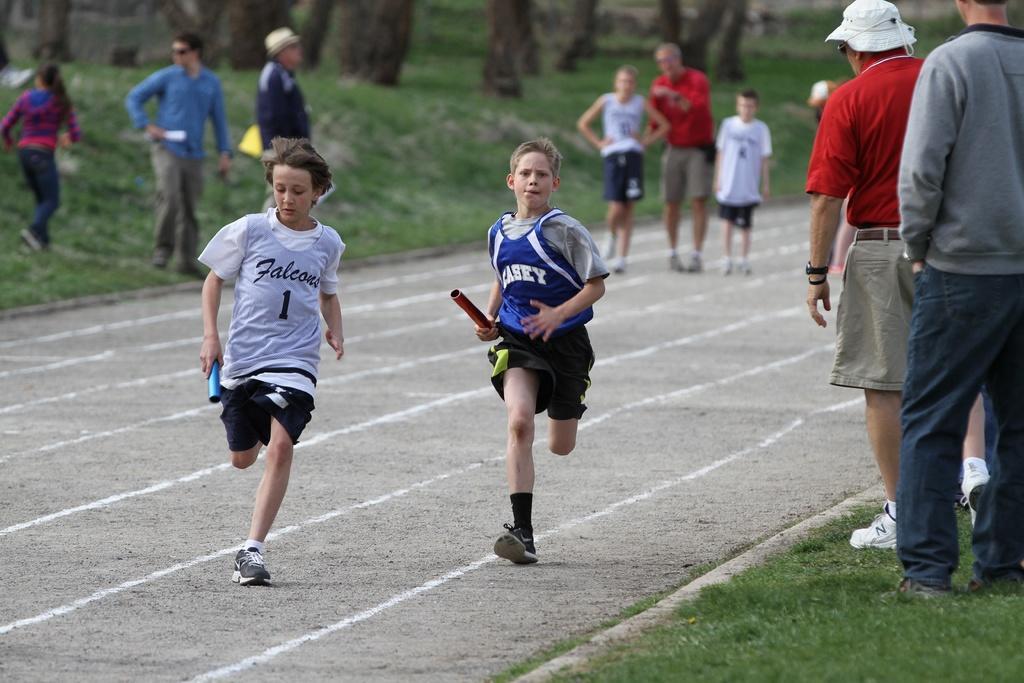Please provide a concise description of this image. In the center of the image there are two boys running on the running track. In the background of the image there are people,grass and tree trunks. To the right side of the image there are two people standing. 